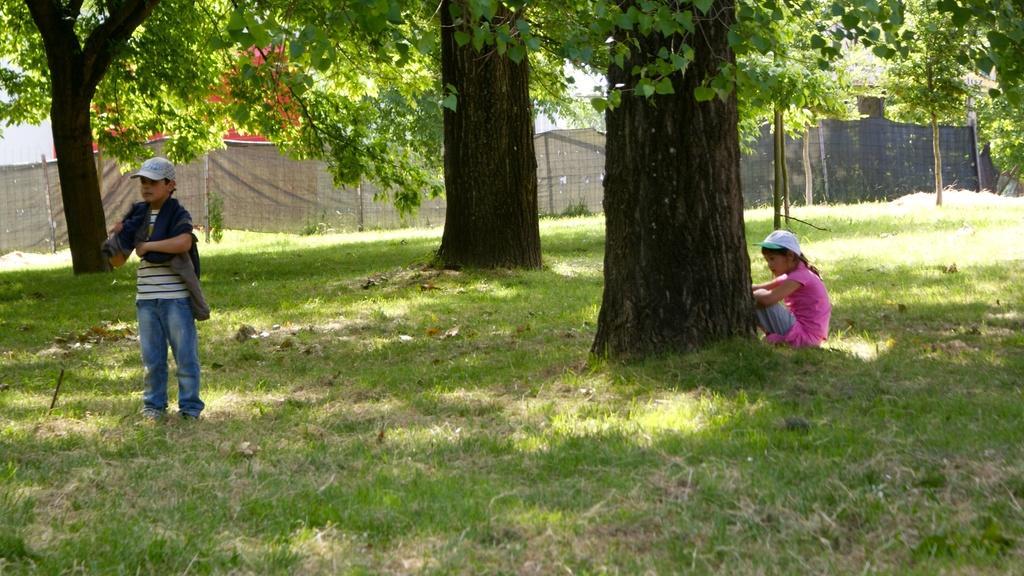In one or two sentences, can you explain what this image depicts? The boy in the white T-shirt who is wearing a cap is standing on the grass. The girl in the pink dress who is wearing a white cap is sitting beside the tree. At the bottom of the picture, we see grass. In the background, we see a grey color sheet as a fence. There are trees and buildings in the background. 